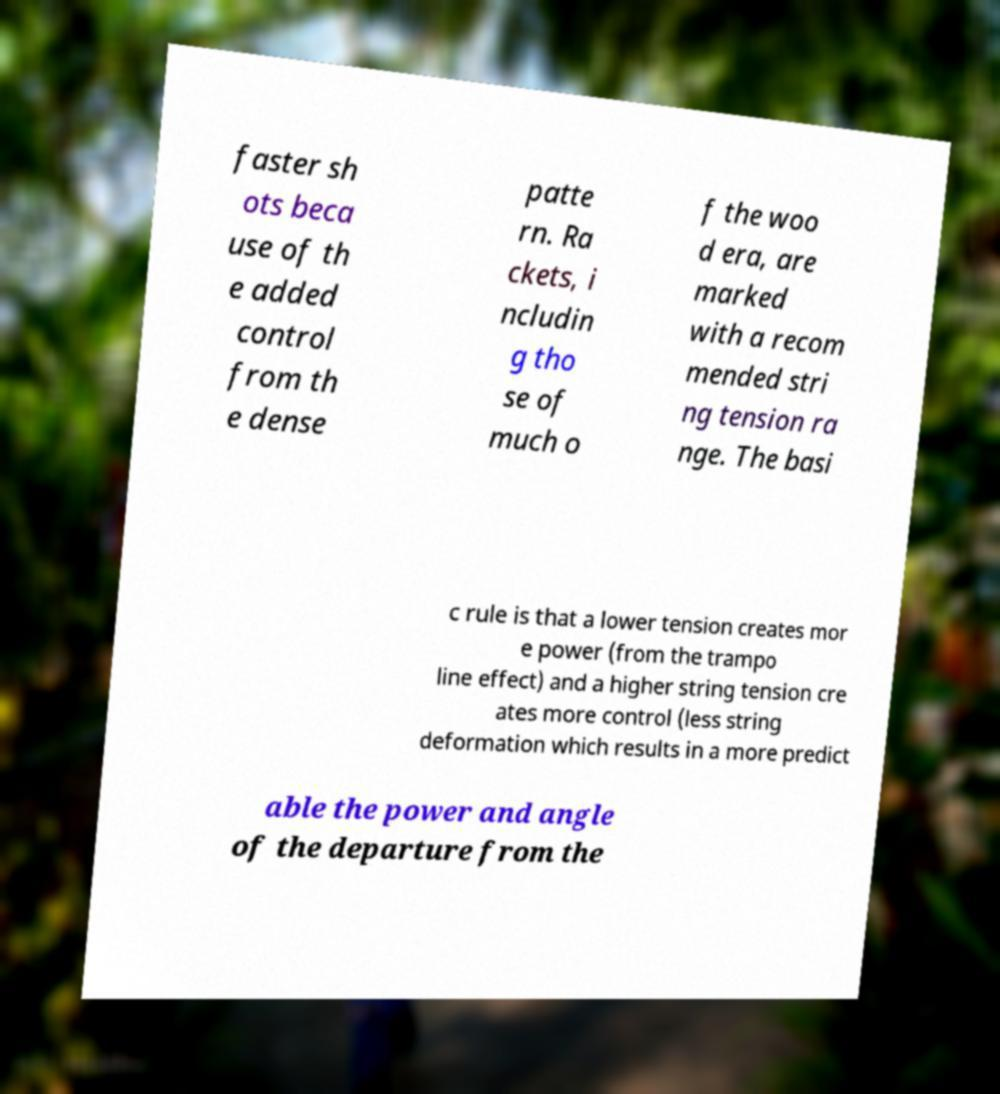For documentation purposes, I need the text within this image transcribed. Could you provide that? faster sh ots beca use of th e added control from th e dense patte rn. Ra ckets, i ncludin g tho se of much o f the woo d era, are marked with a recom mended stri ng tension ra nge. The basi c rule is that a lower tension creates mor e power (from the trampo line effect) and a higher string tension cre ates more control (less string deformation which results in a more predict able the power and angle of the departure from the 